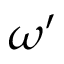<formula> <loc_0><loc_0><loc_500><loc_500>\omega ^ { \prime }</formula> 